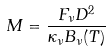Convert formula to latex. <formula><loc_0><loc_0><loc_500><loc_500>M = \frac { F _ { \nu } D ^ { 2 } } { \kappa _ { \nu } B _ { \nu } ( T ) }</formula> 